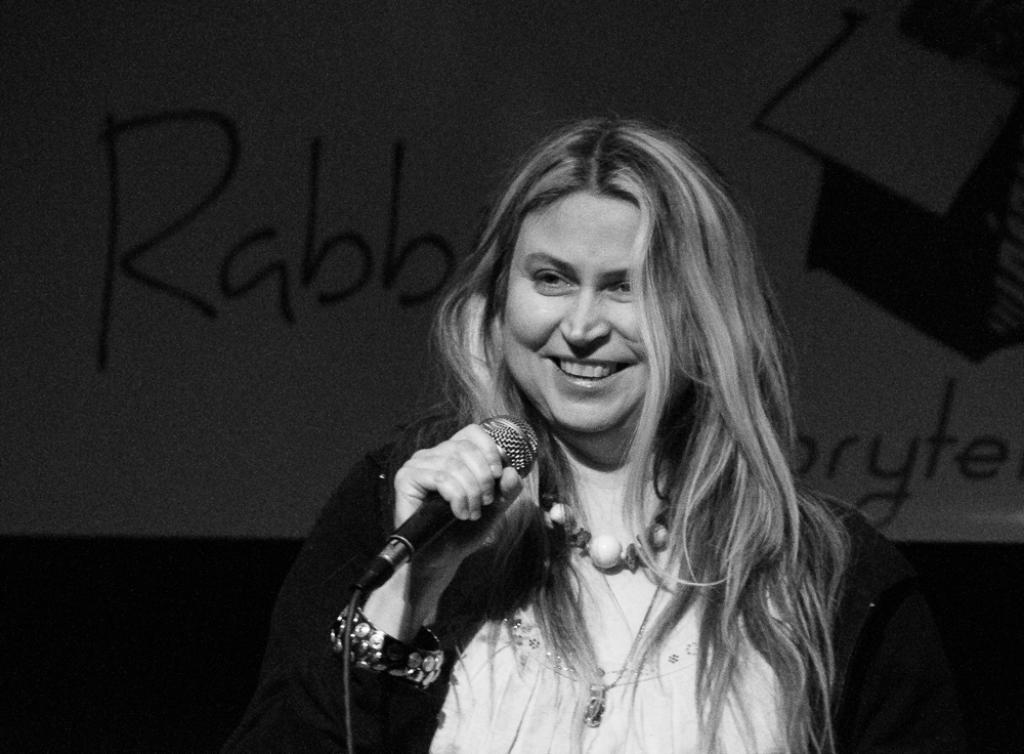What is the color scheme of the image? The image is black and white. Who is the main subject in the image? There is a lady in the center of the image. What is the lady holding in her hand? The lady is holding a mic in her hand. What can be seen in the background of the image? There is a poster in the background of the image. How many spiders are crawling on the lady's shoulder in the image? There are no spiders visible in the image. What type of can is shown on the poster in the background? There is no can present in the image, as the poster is not described in detail. 